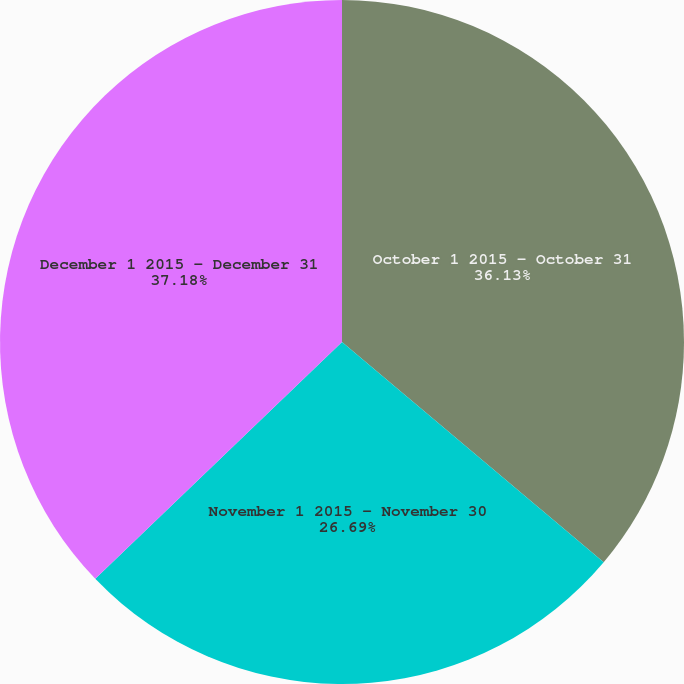Convert chart. <chart><loc_0><loc_0><loc_500><loc_500><pie_chart><fcel>October 1 2015 - October 31<fcel>November 1 2015 - November 30<fcel>December 1 2015 - December 31<nl><fcel>36.13%<fcel>26.69%<fcel>37.17%<nl></chart> 